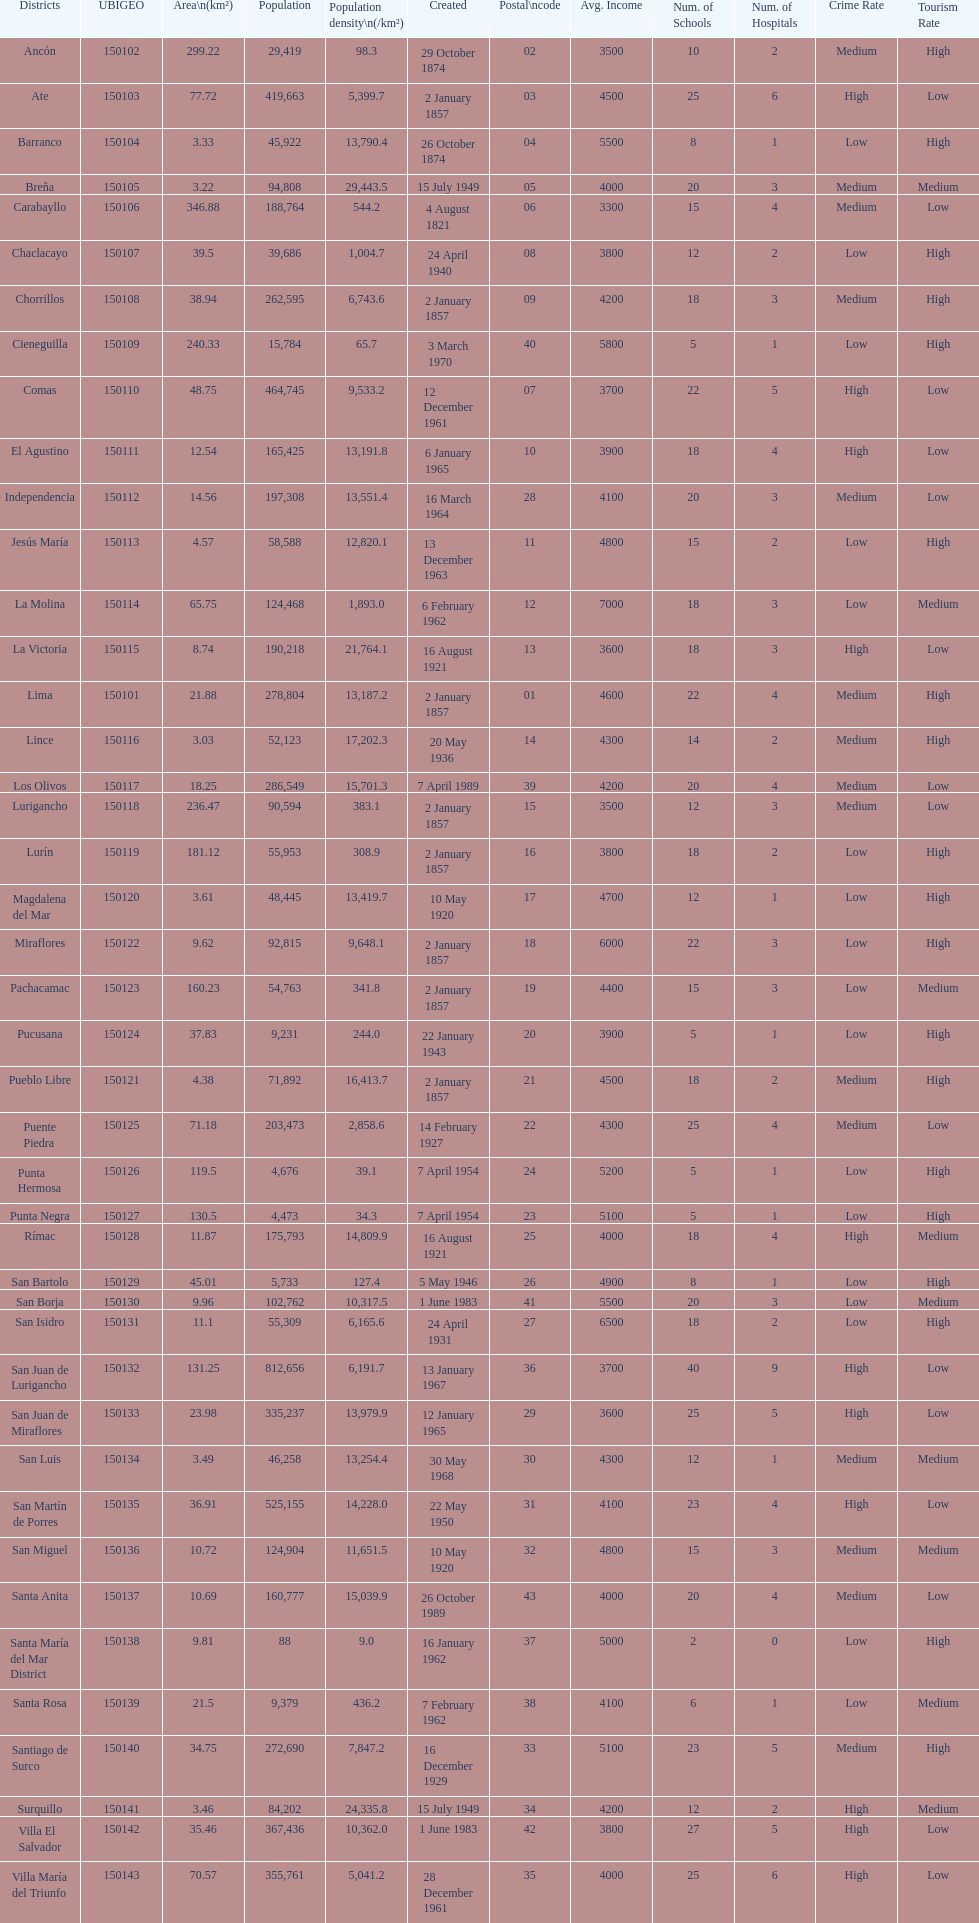What is the total number of districts created in the 1900's? 32. 